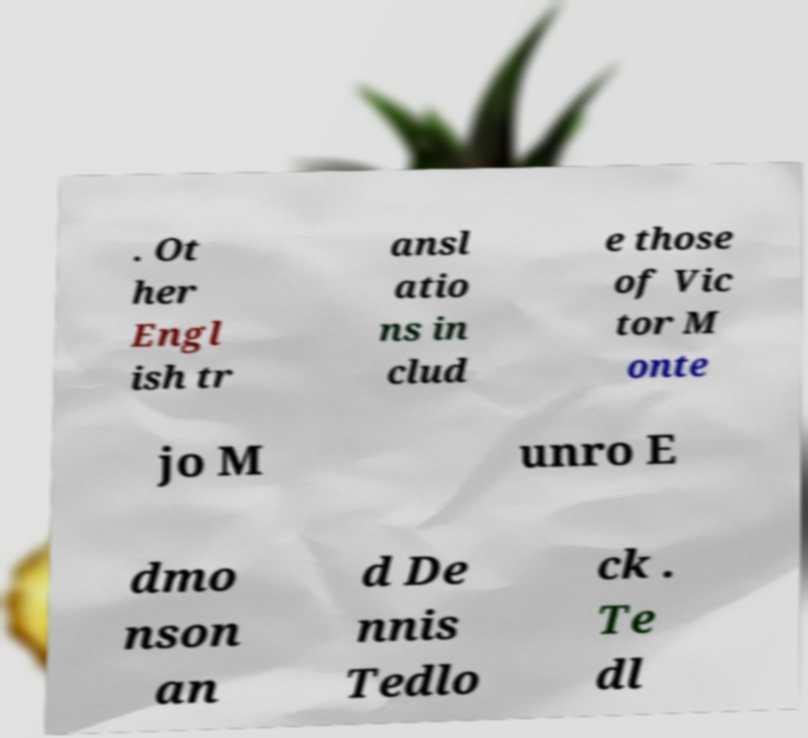Please read and relay the text visible in this image. What does it say? . Ot her Engl ish tr ansl atio ns in clud e those of Vic tor M onte jo M unro E dmo nson an d De nnis Tedlo ck . Te dl 